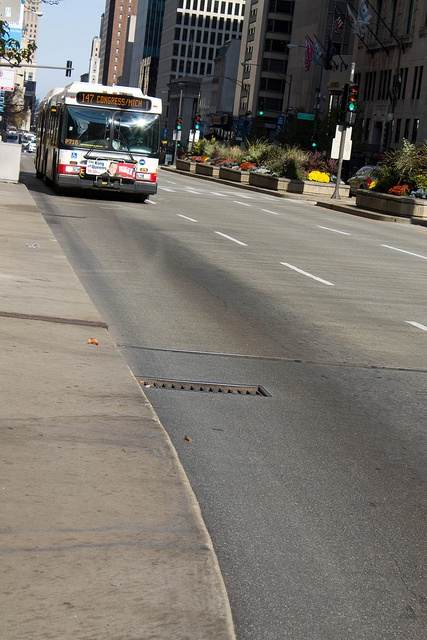Describe the objects in this image and their specific colors. I can see bus in lightgray, black, white, gray, and blue tones, potted plant in lightgray, black, darkgreen, gray, and maroon tones, potted plant in lightgray, black, darkgreen, gray, and tan tones, potted plant in lightgray, black, darkgreen, and gray tones, and traffic light in lightgray, black, gray, and teal tones in this image. 